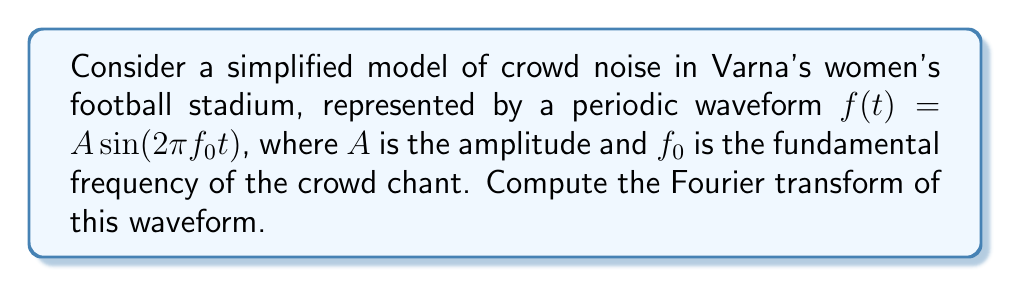Can you solve this math problem? Let's approach this step-by-step:

1) The Fourier transform of a function $f(t)$ is given by:

   $$F(\omega) = \int_{-\infty}^{\infty} f(t) e^{-i\omega t} dt$$

2) In our case, $f(t) = A \sin(2\pi f_0 t)$

3) We can rewrite this using Euler's formula:

   $$\sin(2\pi f_0 t) = \frac{e^{i2\pi f_0 t} - e^{-i2\pi f_0 t}}{2i}$$

4) Substituting this into our waveform:

   $$f(t) = \frac{A}{2i}(e^{i2\pi f_0 t} - e^{-i2\pi f_0 t})$$

5) Now let's compute the Fourier transform:

   $$F(\omega) = \int_{-\infty}^{\infty} \frac{A}{2i}(e^{i2\pi f_0 t} - e^{-i2\pi f_0 t}) e^{-i\omega t} dt$$

6) This can be separated into two integrals:

   $$F(\omega) = \frac{A}{2i}\int_{-\infty}^{\infty} e^{i(2\pi f_0 - \omega)t} dt - \frac{A}{2i}\int_{-\infty}^{\infty} e^{-i(2\pi f_0 + \omega)t} dt$$

7) These integrals result in delta functions:

   $$F(\omega) = \frac{A}{2i}\cdot 2\pi \delta(\omega - 2\pi f_0) - \frac{A}{2i}\cdot 2\pi \delta(\omega + 2\pi f_0)$$

8) Simplifying:

   $$F(\omega) = \pi A i[\delta(\omega - 2\pi f_0) - \delta(\omega + 2\pi f_0)]$$

This is the Fourier transform of our simplified crowd noise waveform.
Answer: $\pi A i[\delta(\omega - 2\pi f_0) - \delta(\omega + 2\pi f_0)]$ 